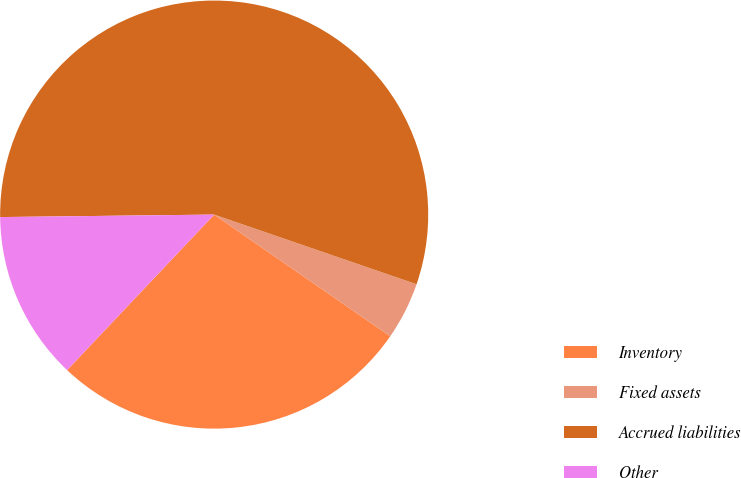Convert chart. <chart><loc_0><loc_0><loc_500><loc_500><pie_chart><fcel>Inventory<fcel>Fixed assets<fcel>Accrued liabilities<fcel>Other<nl><fcel>27.43%<fcel>4.35%<fcel>55.46%<fcel>12.76%<nl></chart> 